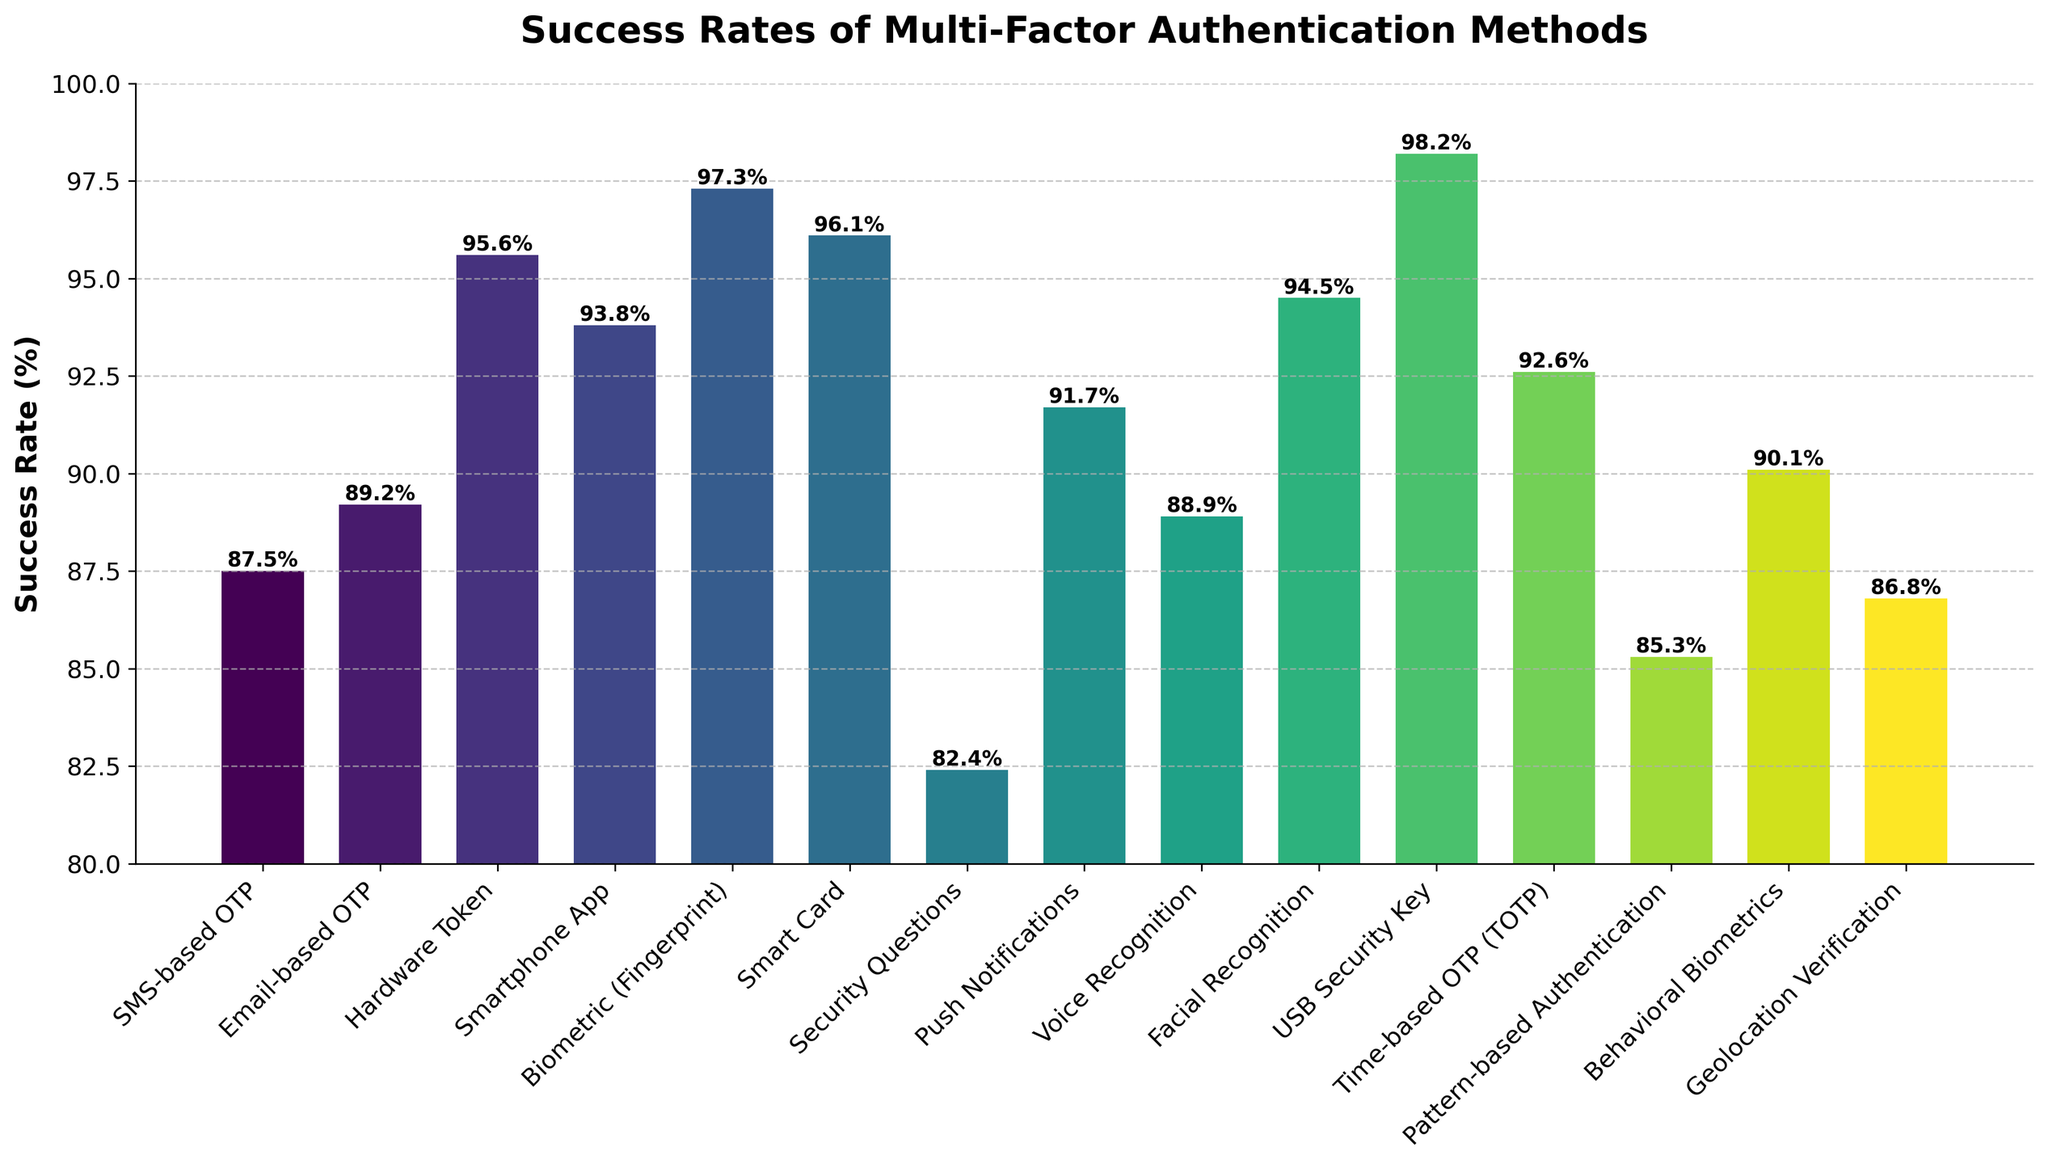Which authentication method has the highest success rate? The bar representing "USB Security Key" is the highest among all bars in the chart, indicating that it has the highest success rate.
Answer: USB Security Key What is the difference in success rate between the least and most successful methods? The least successful method is "Security Questions" with 82.4%, and the most successful is "USB Security Key" with 98.2%. The difference is calculated as 98.2% - 82.4% = 15.8%.
Answer: 15.8% Which two methods have success rates closest to 90%? From the chart, "Behavioral Biometrics" has a success rate of 90.1%, and "Push Notifications" has a success rate of 91.7%, both near 90%.
Answer: Behavioral Biometrics, Push Notifications How many methods have success rates above 95%? By visually inspecting the bars, the methods with success rates above 95% are "Hardware Token", "Smart Card", "Biometric (Fingerprint)", "Facial Recognition", and "USB Security Key". There are five such methods.
Answer: 5 What is the average success rate of "Email-based OTP", "Voice Recognition", and "Pattern-based Authentication"? The success rates are 89.2% for "Email-based OTP", 88.9% for "Voice Recognition", and 85.3% for "Pattern-based Authentication". The average is calculated as (89.2 + 88.9 + 85.3) / 3 = 87.8%.
Answer: 87.8% Compare the success rates of biometric methods with non-biometric methods. Which has a higher average success rate? Biometric methods are "Biometric (Fingerprint)", "Voice Recognition", "Facial Recognition", and "Behavioral Biometrics", with rates of 97.3%, 88.9%, 94.5%, and 90.1% respectively. Non-biometric methods' success rates include the remaining methods. Calculate averages:
Biometric: (97.3 + 88.9 + 94.5 + 90.1) / 4 = 92.7%
Non-Biometric: Sum of remaining success rates / number of non-biometric methods.
Higher average: 92.7% for Biometric, indicating biometric methods have a higher average success rate.
Answer: Biometric What is the difference in success rate between "SMS-based OTP" and "Time-based OTP"? The success rate for "SMS-based OTP" is 87.5%, and for "Time-based OTP" it is 92.6%. The difference is calculated as 92.6% - 87.5% = 5.1%.
Answer: 5.1% Which method has a higher success rate: "Smartphone App" or "Facial Recognition"? From the bar heights, "Facial Recognition" has a success rate of 94.5%, and "Smartphone App" has a success rate of 93.8%. Thus, "Facial Recognition" is higher.
Answer: Facial Recognition How many methods have success rates between 85% and 90%? The chart shows the following methods in this range: "SMS-based OTP", "Email-based OTP", "Voice Recognition", "Geolocation Verification", and "Pattern-based Authentication". There are five methods in this range.
Answer: 5 